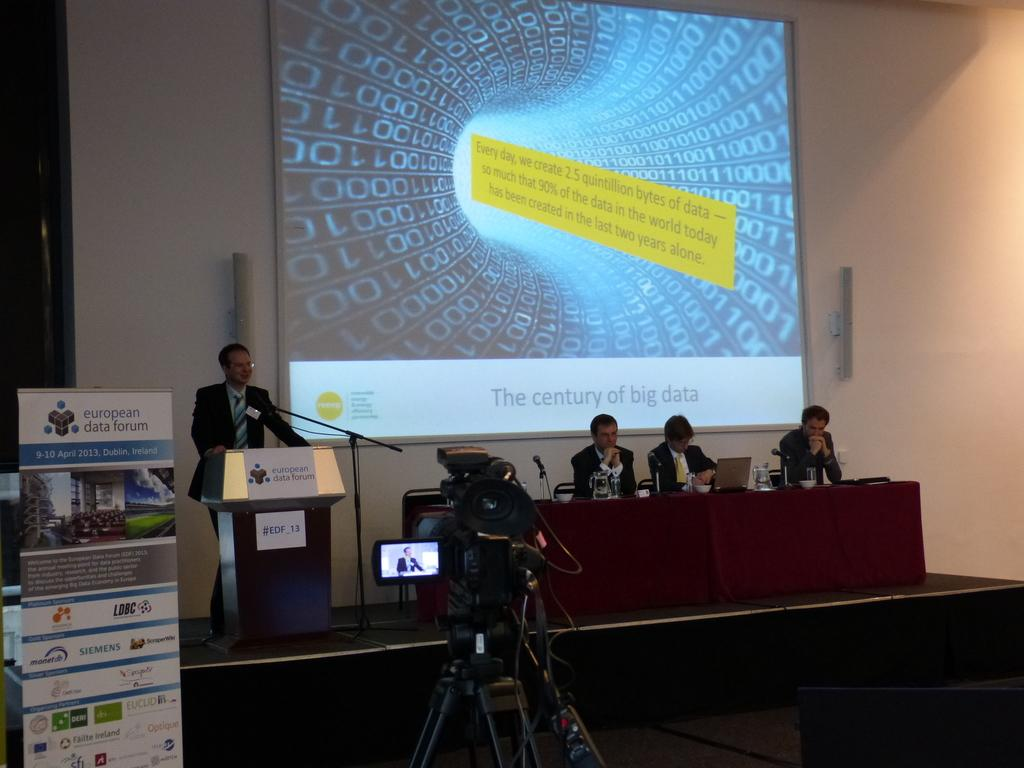<image>
Describe the image concisely. Several people sit in front of a screen that says "The century of big data" 